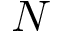Convert formula to latex. <formula><loc_0><loc_0><loc_500><loc_500>N</formula> 